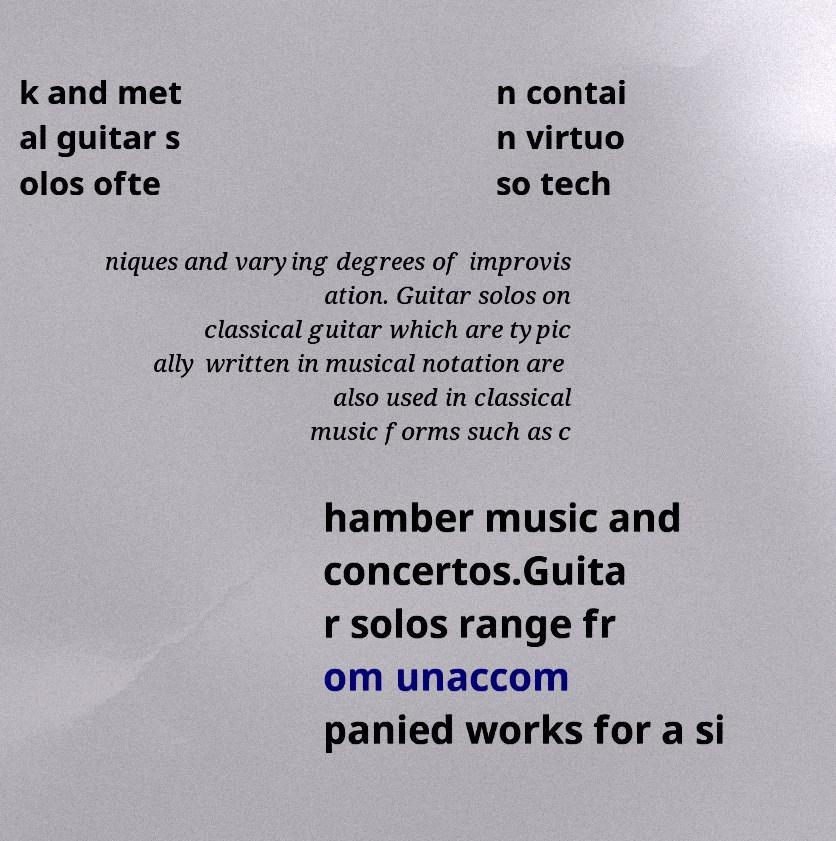Please identify and transcribe the text found in this image. k and met al guitar s olos ofte n contai n virtuo so tech niques and varying degrees of improvis ation. Guitar solos on classical guitar which are typic ally written in musical notation are also used in classical music forms such as c hamber music and concertos.Guita r solos range fr om unaccom panied works for a si 